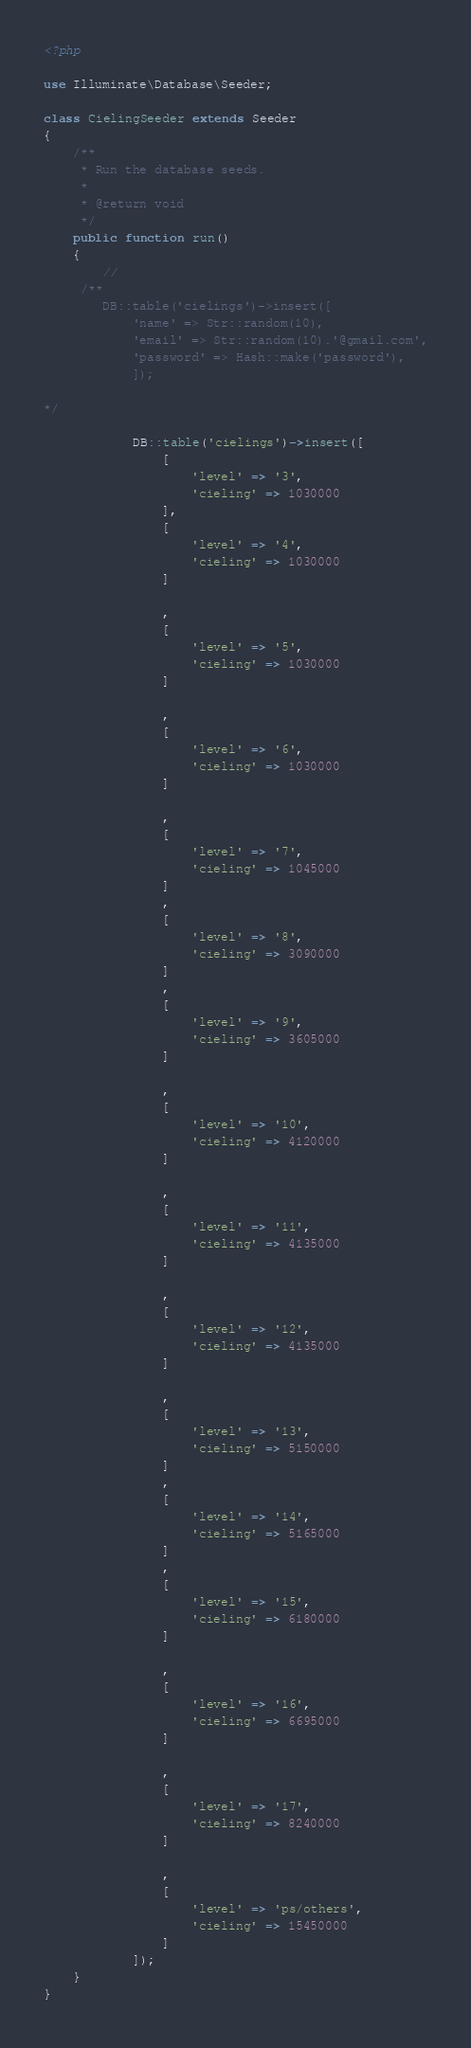<code> <loc_0><loc_0><loc_500><loc_500><_PHP_><?php

use Illuminate\Database\Seeder;

class CielingSeeder extends Seeder
{
    /**
     * Run the database seeds.
     *
     * @return void
     */
    public function run()
    {
        //
     /** 
        DB::table('cielings')->insert([
            'name' => Str::random(10),
            'email' => Str::random(10).'@gmail.com',
            'password' => Hash::make('password'),
            ]);

*/

            DB::table('cielings')->insert([
                [
                    'level' => '3',
                    'cieling' => 1030000
                ],
                [
                    'level' => '4',
                    'cieling' => 1030000
                ]

                ,
                [
                    'level' => '5',
                    'cieling' => 1030000
                ]

                ,
                [
                    'level' => '6',
                    'cieling' => 1030000
                ]

                ,
                [
                    'level' => '7',
                    'cieling' => 1045000
                ]
                ,
                [
                    'level' => '8',
                    'cieling' => 3090000
                ]
                ,
                [
                    'level' => '9',
                    'cieling' => 3605000
                ]

                ,
                [
                    'level' => '10',
                    'cieling' => 4120000
                ]

                ,
                [
                    'level' => '11',
                    'cieling' => 4135000
                ]

                ,
                [
                    'level' => '12',
                    'cieling' => 4135000
                ]

                ,
                [
                    'level' => '13',
                    'cieling' => 5150000
                ]
                ,
                [
                    'level' => '14',
                    'cieling' => 5165000
                ]
                ,
                [
                    'level' => '15',
                    'cieling' => 6180000
                ]

                ,
                [
                    'level' => '16',
                    'cieling' => 6695000
                ]

                ,
                [
                    'level' => '17',
                    'cieling' => 8240000
                ]

                ,
                [
                    'level' => 'ps/others',
                    'cieling' => 15450000
                ]
            ]);
    }
}
</code> 